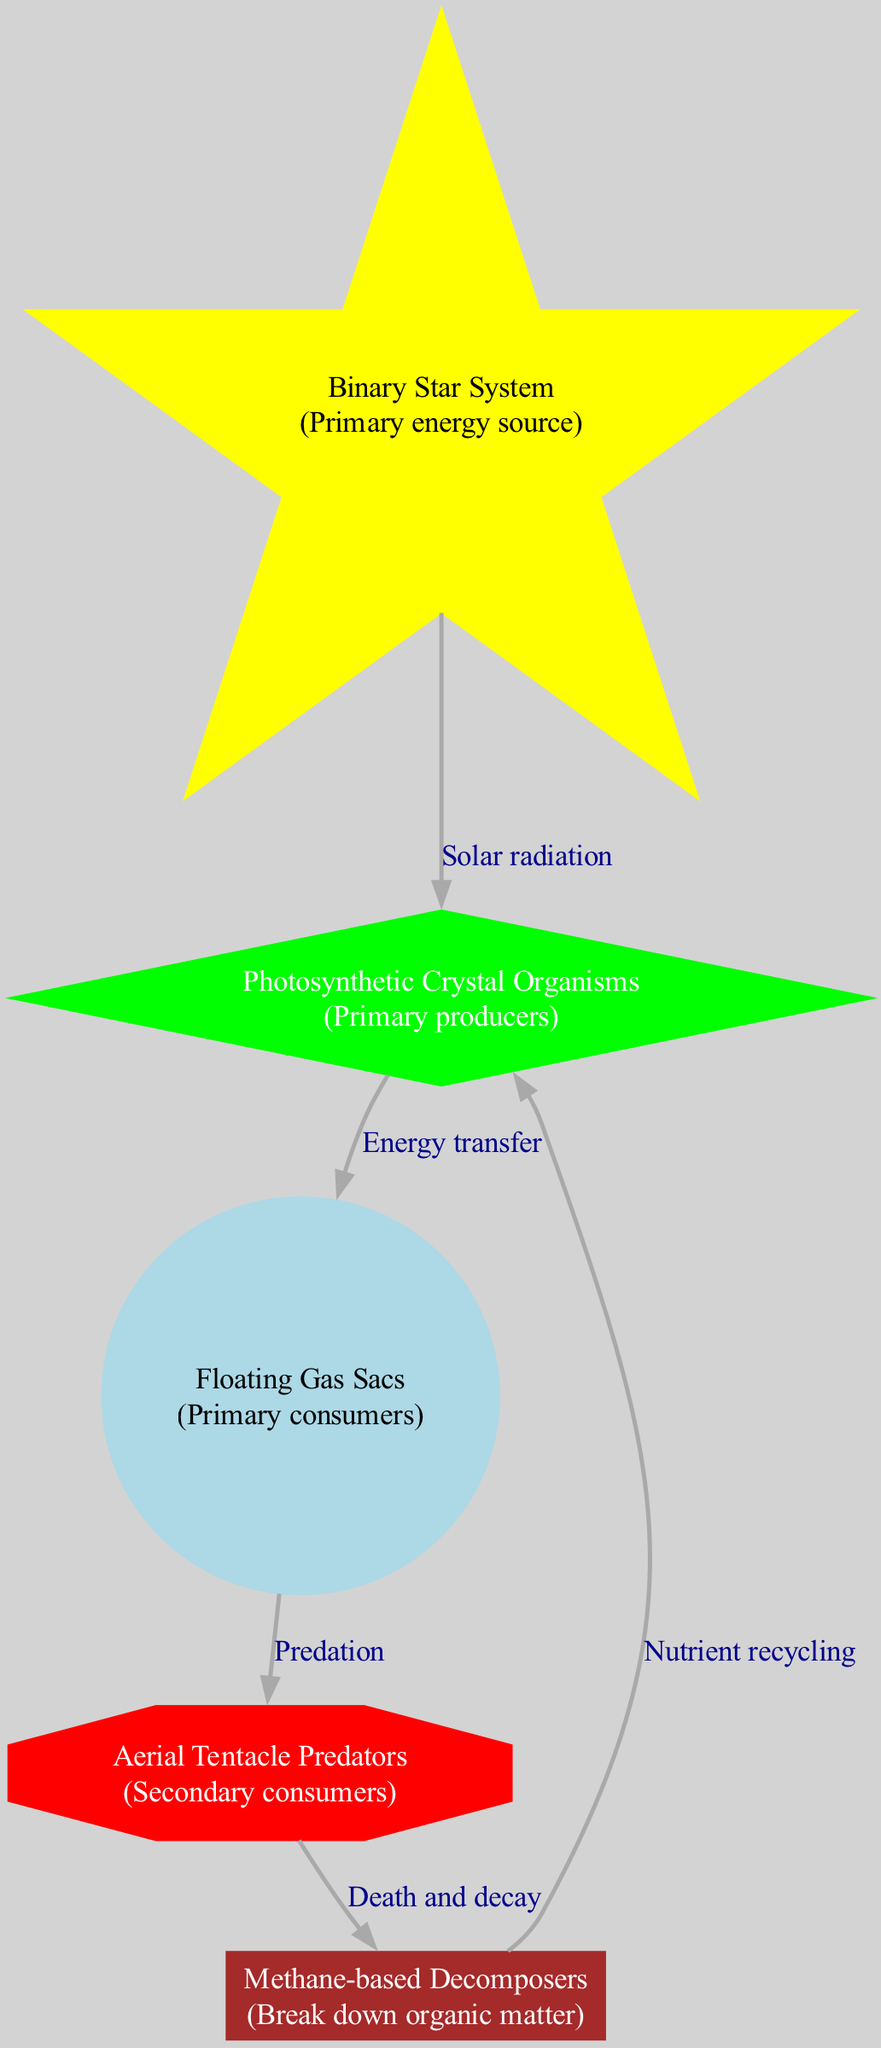What is the primary energy source in this ecosystem? The diagram indicates that the primary energy source is the "Binary Star System". This is shown as the first node in the diagram, labeled with this description.
Answer: Binary Star System How many nodes are present in this diagram? By counting the nodes listed in the diagram, there are five nodes: Binary Star System, Photosynthetic Crystal Organisms, Floating Gas Sacs, Aerial Tentacle Predators, and Methane-based Decomposers.
Answer: 5 What type of relationship exists between Photosynthetic Crystal Organisms and Floating Gas Sacs? The diagram shows an "Energy transfer" relationship between these two nodes. The edge connecting them is labeled accordingly, indicating Photosynthetic Crystal Organisms provide energy to Floating Gas Sacs.
Answer: Energy transfer Which node acts as the secondary consumer? The diagram designates "Aerial Tentacle Predators" as the secondary consumer. This can be seen as the node that receives energy from the primary consumers, Floating Gas Sacs.
Answer: Aerial Tentacle Predators What function do Methane-based Decomposers serve in the energy flow? Methane-based Decomposers are indicated in the diagram to "Break down organic matter," which is crucial for nutrient recycling within the ecosystem as shown by their connection to Photosynthetic Crystal Organisms.
Answer: Break down organic matter What process does the edge between Aerial Tentacle Predators and Methane-based Decomposers represent? The relationship is labeled as "Death and decay," indicating that the energy from Aerial Tentacle Predators transfers to Methane-based Decomposers through the process of decomposition after the death of predators.
Answer: Death and decay Which node is directly influenced by solar radiation according to the diagram? The diagram depicts that the "Photosynthetic Crystal Organisms" receive energy directly from the "Binary Star System" through the edge labeled "Solar radiation."
Answer: Photosynthetic Crystal Organisms How does nutrient recycling occur in this ecosystem? Nutrient recycling happens as depicted in the diagram, where the edge between "Methane-based Decomposers" and "Photosynthetic Crystal Organisms" is labeled "Nutrient recycling," indicating that decomposers return nutrients to the primary producers.
Answer: Nutrient recycling 